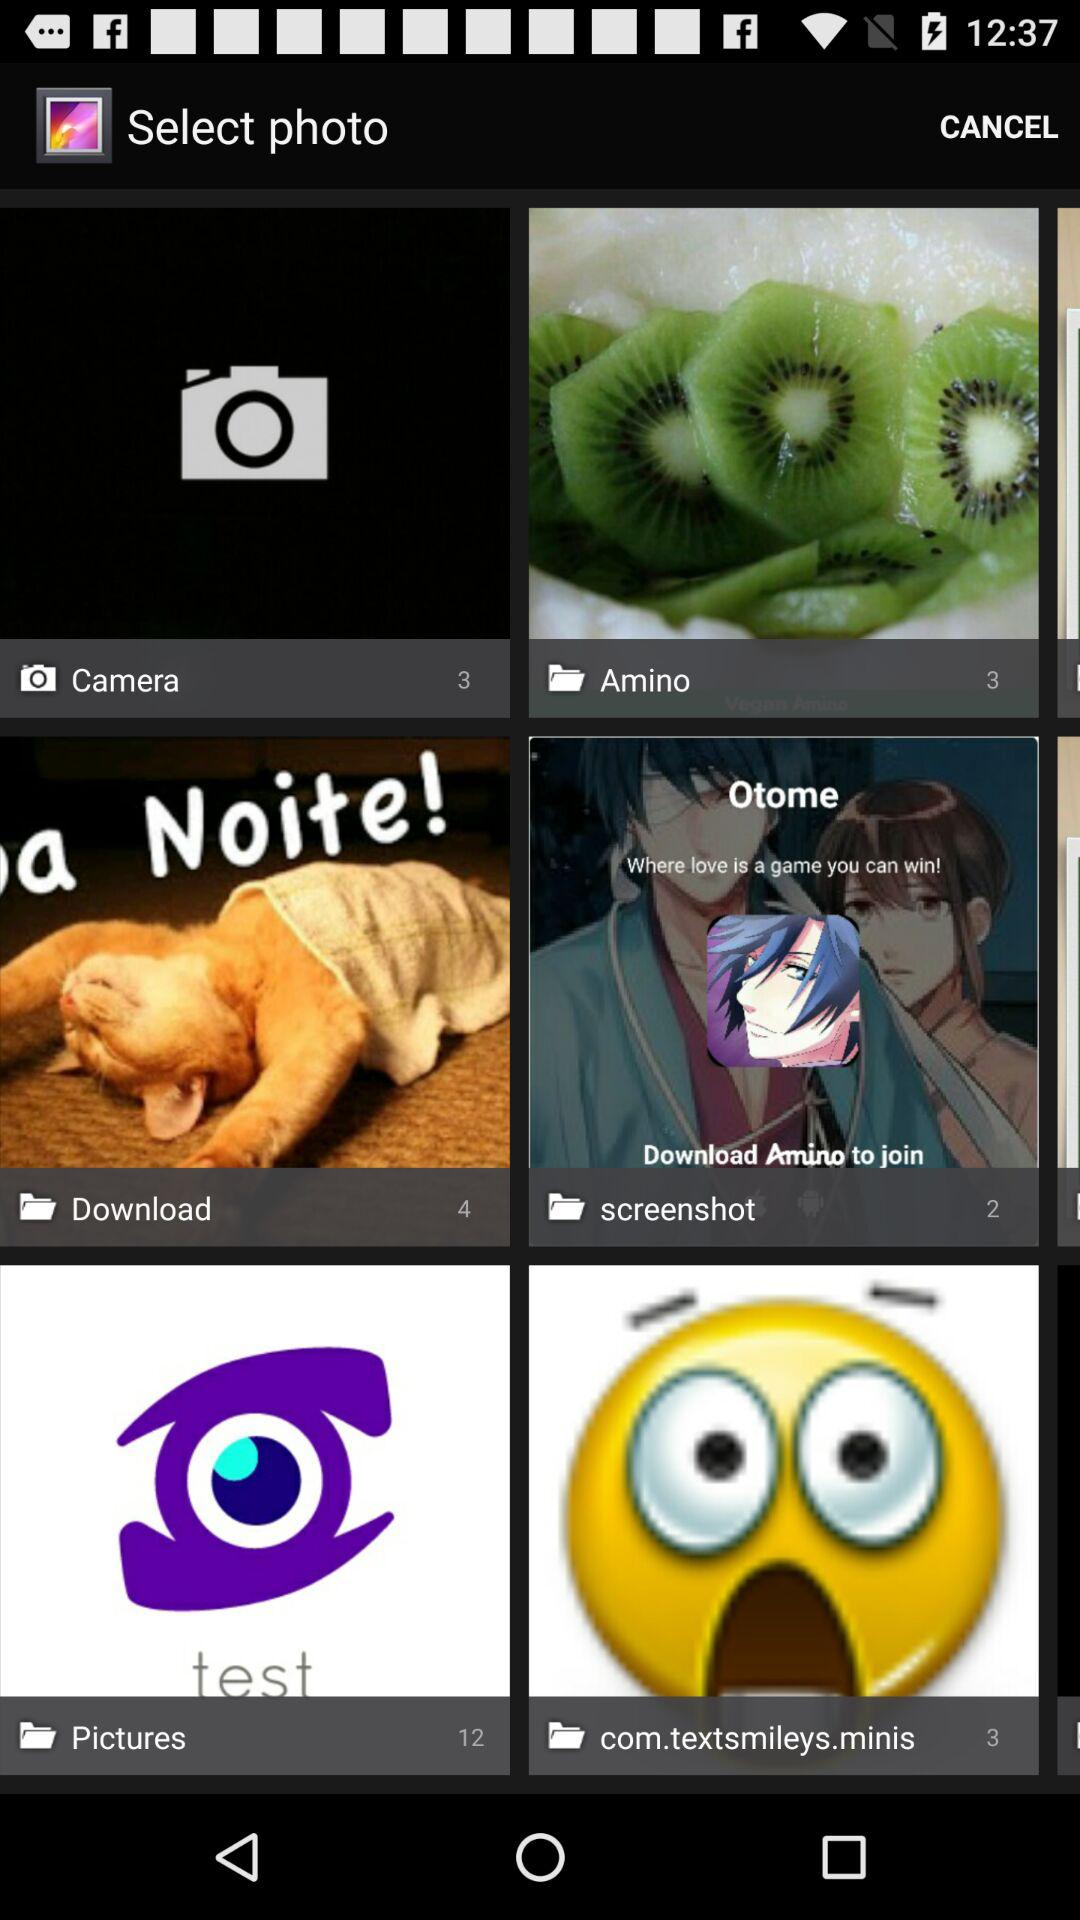How many images are there in the "Pictures" folder? There are 12 images. 